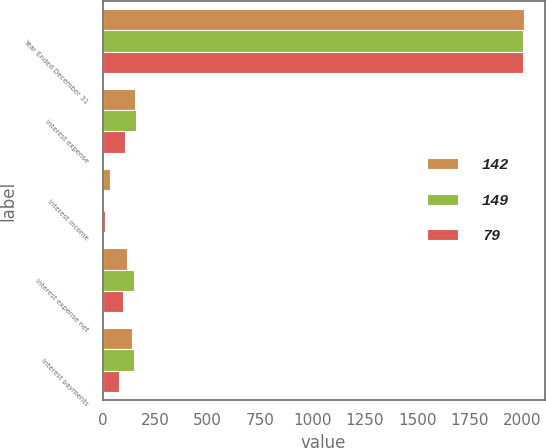<chart> <loc_0><loc_0><loc_500><loc_500><stacked_bar_chart><ecel><fcel>Year Ended December 31<fcel>Interest expense<fcel>Interest income<fcel>Interest expense net<fcel>Interest payments<nl><fcel>142<fcel>2005<fcel>154<fcel>36<fcel>118<fcel>142<nl><fcel>149<fcel>2004<fcel>157<fcel>9<fcel>148<fcel>149<nl><fcel>79<fcel>2003<fcel>108<fcel>10<fcel>98<fcel>79<nl></chart> 